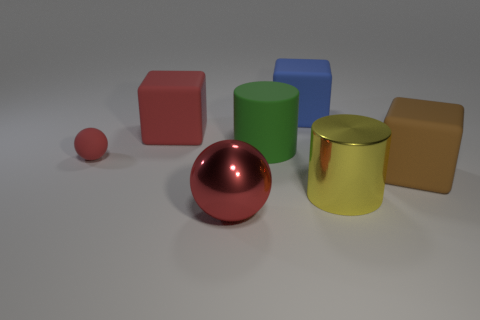Subtract all large red blocks. How many blocks are left? 2 Add 1 cyan cubes. How many objects exist? 8 Subtract all blue cubes. How many cubes are left? 2 Subtract 2 balls. How many balls are left? 0 Add 4 brown things. How many brown things exist? 5 Subtract 0 cyan cylinders. How many objects are left? 7 Subtract all cylinders. How many objects are left? 5 Subtract all purple cylinders. Subtract all green cubes. How many cylinders are left? 2 Subtract all red cubes. Subtract all large yellow things. How many objects are left? 5 Add 3 large red objects. How many large red objects are left? 5 